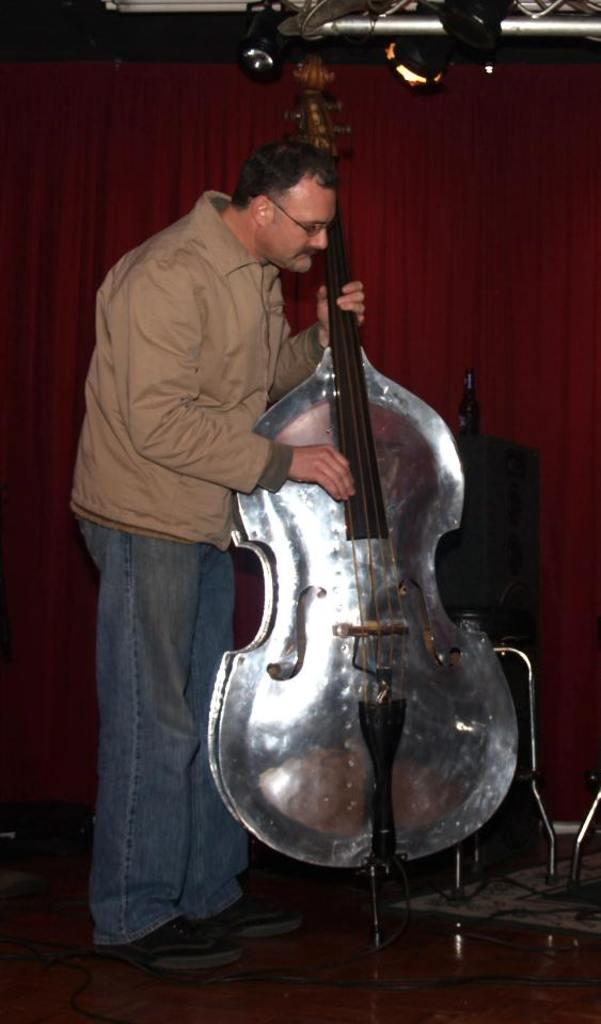Who is present in the image? There is a man in the image. What is the man doing in the image? The man is standing on the floor and holding a bass in his hands. What can be seen in the background of the image? There is a curtain and cables visible in the background of the image. What type of plant is growing out of the man's nerve in the image? A: There is no plant or nerve present in the image; it features a man holding a bass while standing on the floor. 